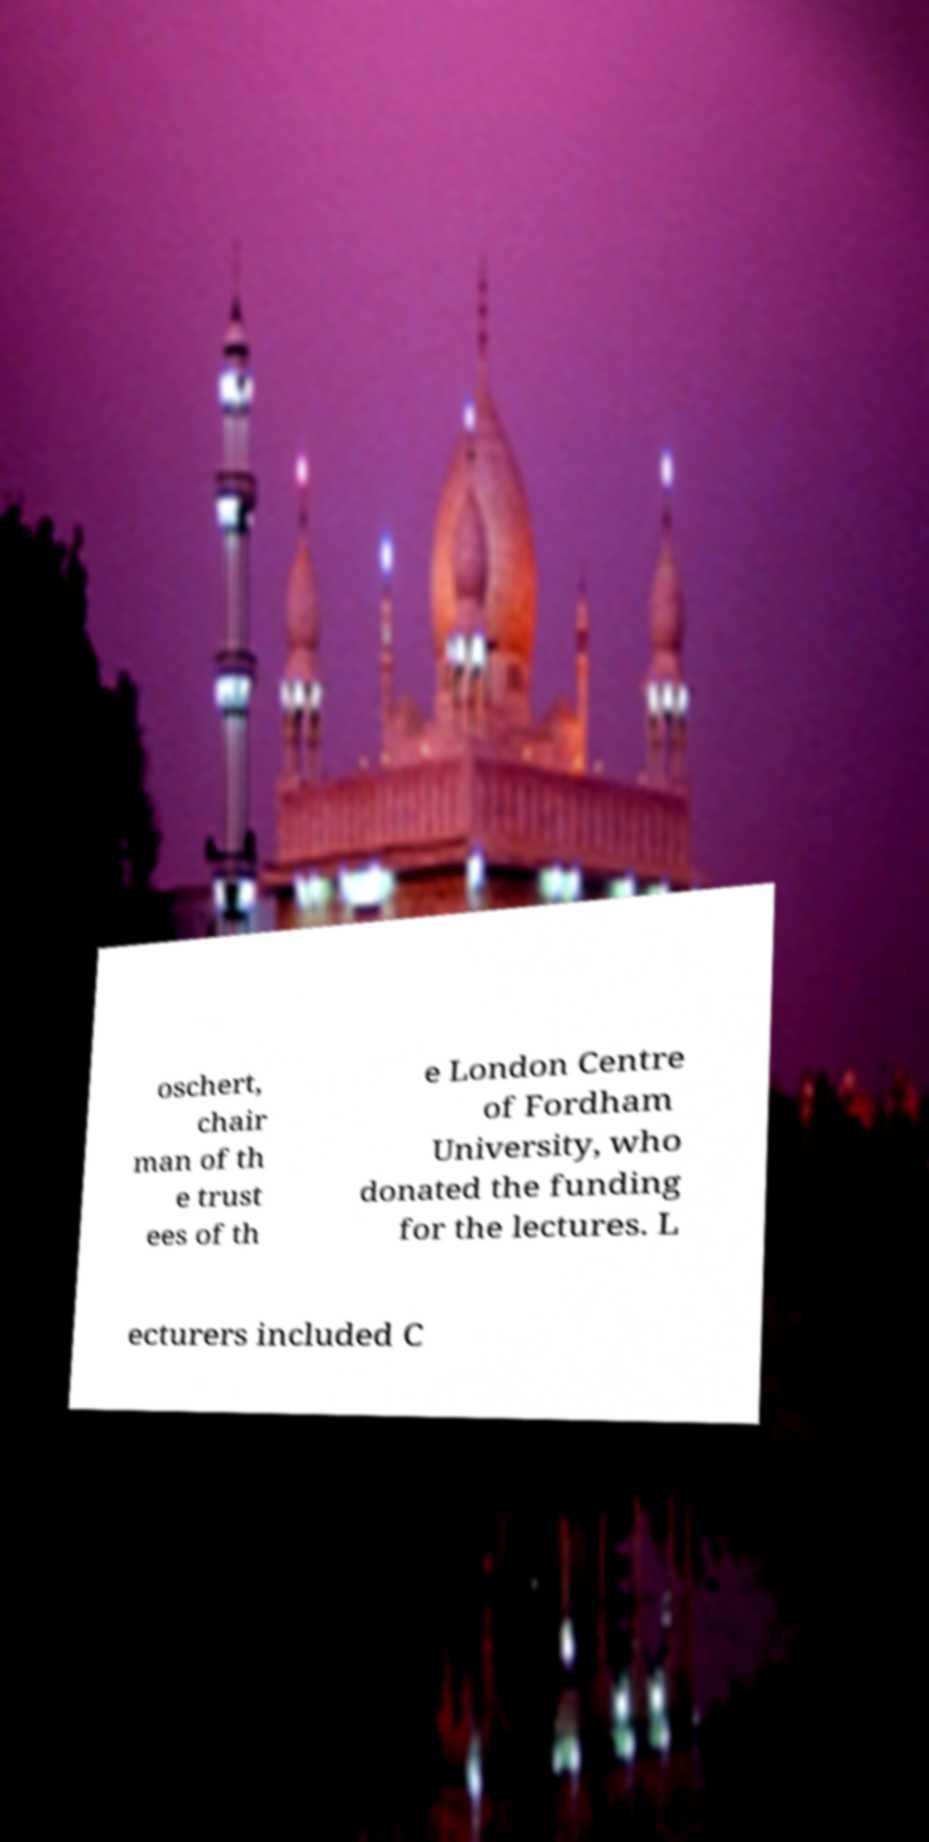Could you extract and type out the text from this image? oschert, chair man of th e trust ees of th e London Centre of Fordham University, who donated the funding for the lectures. L ecturers included C 